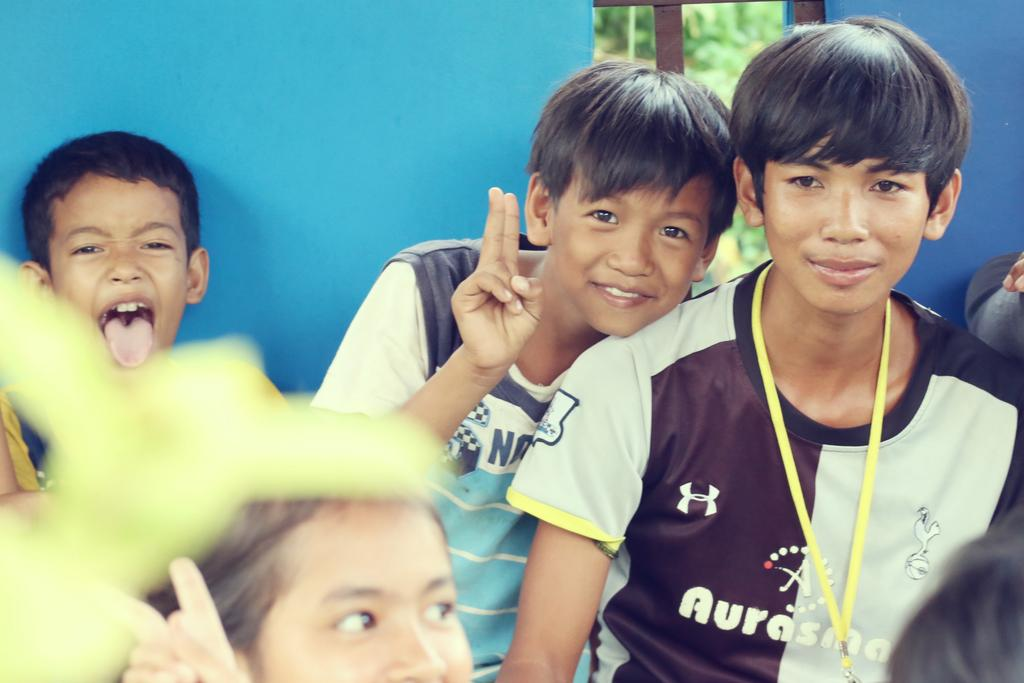<image>
Summarize the visual content of the image. Group of children taking a picture while one wears a shirt that says "Aurasma". 